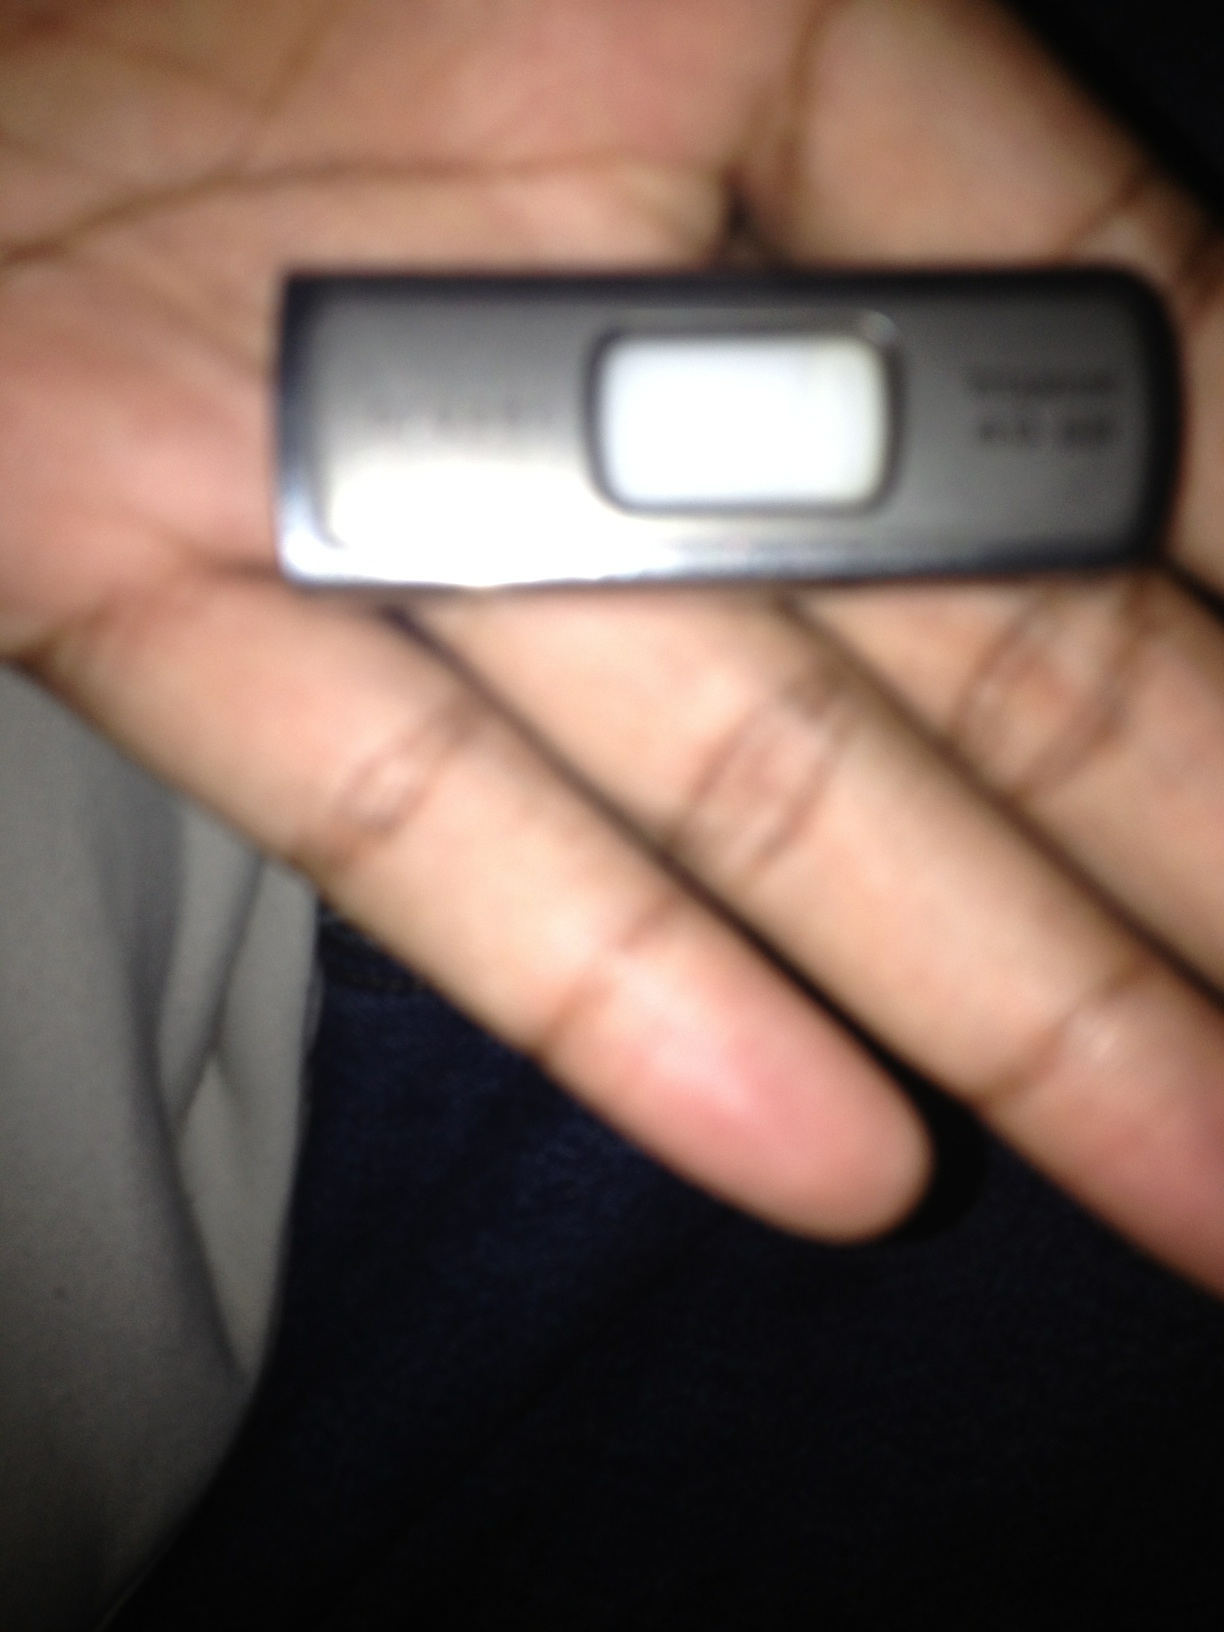Imagine this flash drive contains secret plans for a space mission. Describe what the plans could involve. Envision a USB flash drive that contains the highly classified plans for a new space mission. The plans might include detailed blueprints of a state-of-the-art spacecraft capable of reaching Mars. Within the flash drive, there could be specifications for advanced life support systems, innovative propulsion technologies, and unique habitat modules designed for long-term human habitation on the Martian surface. Additionally, the drive may hold complex algorithms for autonomous navigation and landing, logistical plans for transporting supplies, and a schedule for launching multiple missions in succession to establish a sustainable human presence on Mars. 